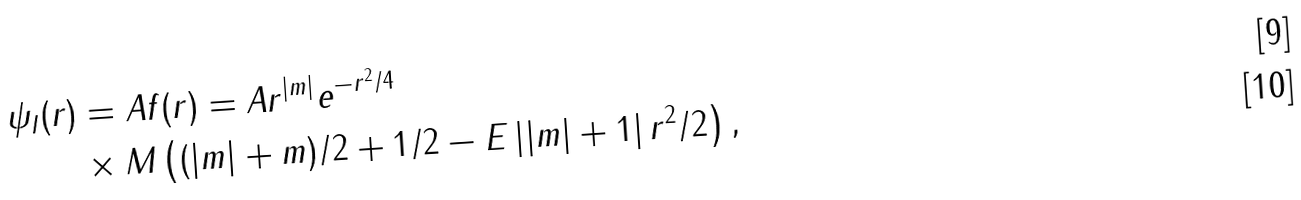Convert formula to latex. <formula><loc_0><loc_0><loc_500><loc_500>\psi _ { I } ( r ) & = A f ( r ) = A r ^ { | m | } e ^ { - r ^ { 2 } / 4 } \\ & \times M \left ( ( | m | + m ) / 2 + 1 / 2 - E \left | | m | + 1 \right | r ^ { 2 } / 2 \right ) ,</formula> 